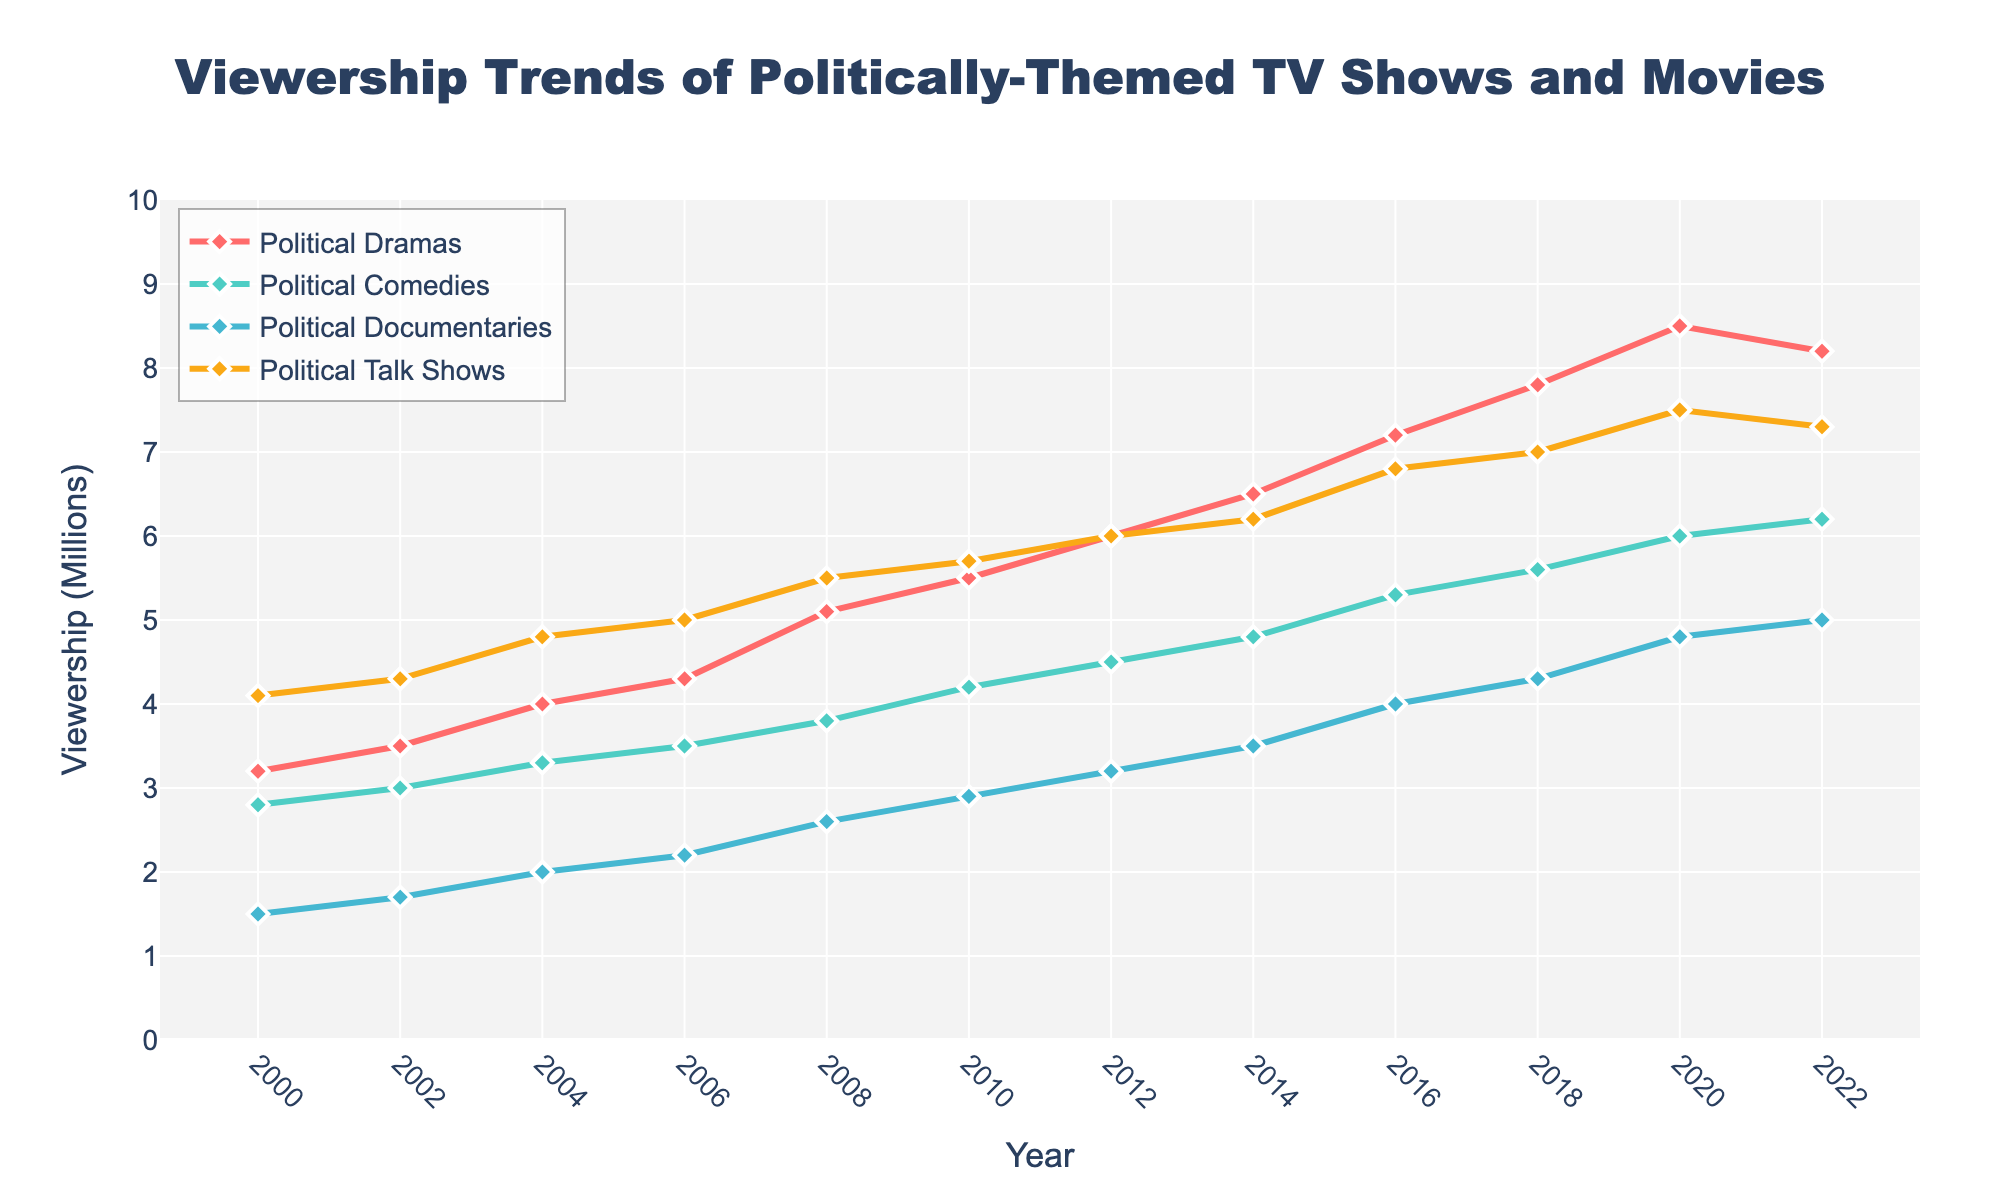What's the trend in viewership for Political Dramas from 2000 to 2022? The viewership for Political Dramas increased from 3.2 million in 2000 to a peak of 8.5 million in 2020, before slightly decreasing to 8.2 million in 2022.
Answer: Increasing trend with a slight decrease after 2020 Which type of politically-themed show had the highest viewership in 2008? In 2008, Political Talk Shows had the highest viewership at 5.5 million, compared to Political Dramas (5.1 million), Political Comedies (3.8 million), and Political Documentaries (2.6 million).
Answer: Political Talk Shows By how much did Political Documentaries' viewership increase from 2000 to 2022? The viewership for Political Documentaries increased from 1.5 million in 2000 to 5.0 million in 2022. The increase is 5.0 - 1.5 = 3.5 million.
Answer: 3.5 million In which year did Political Comedies' viewership surpass 5 million? Political Comedies' viewership surpassed 5 million in 2016 when it reached 5.3 million.
Answer: 2016 Compare the average viewership of Political Dramas and Political Comedies over the period from 2000 to 2022. To find the average viewership for each: 
Political Dramas: (3.2 + 3.5 + 4.0 + 4.3 + 5.1 + 5.5 + 6.0 + 6.5 + 7.2 + 7.8 + 8.5 + 8.2) / 12 = 5.9917 
Political Comedies: (2.8 + 3.0 + 3.3 + 3.5 + 3.8 + 4.2 + 4.5 + 4.8 + 5.3 + 5.6 + 6.0 + 6.2) / 12 = 4.15 
Comparing these averages, Political Dramas have a higher average viewership.
Answer: Political Dramas have a higher average viewership Which genre experienced a steady increase in viewership without any drop from 2000 to 2022? Political Comedies experienced a steady increase in viewership from 2.8 million in 2000 to 6.2 million in 2022 without any drop.
Answer: Political Comedies How did viewership for Political Talk Shows change between 2018 and 2022? The viewership for Political Talk Shows increased from 7.0 million in 2018 to a peak of 7.5 million in 2020, followed by a slight decrease to 7.3 million in 2022.
Answer: Increased, then slightly decreased What was the smallest difference in viewership between Political Dramas and Political Documentaries in any given year? The smallest difference was in 2022 when the viewership for Political Dramas was 8.2 million and for Political Documentaries was 5.0 million. The difference is 8.2 - 5.0 = 3.2 million.
Answer: 3.2 million From the year 2000 to 2022, which genre saw the least increase in viewership? Political Documentaries saw the least increase in viewership, starting at 1.5 million in 2000 and rising to 5.0 million in 2022—a 3.5 million increase.
Answer: Political Documentaries 